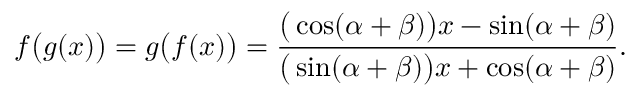<formula> <loc_0><loc_0><loc_500><loc_500>f { \left ( } g ( x ) { \right ) } = g { \left ( } f ( x ) { \right ) } = { \frac { { \left ( } \cos ( \alpha + \beta ) { \right ) } x - \sin ( \alpha + \beta ) } { { \left ( } \sin ( \alpha + \beta ) { \right ) } x + \cos ( \alpha + \beta ) } } .</formula> 